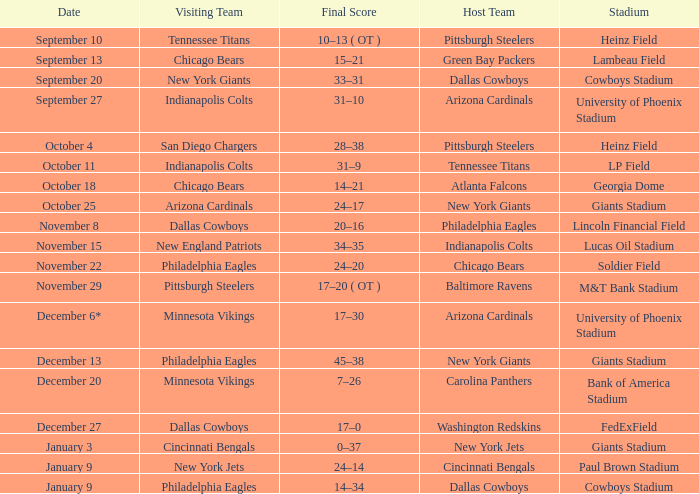Can you tell me the ultimate score for december 27? 17–0. 